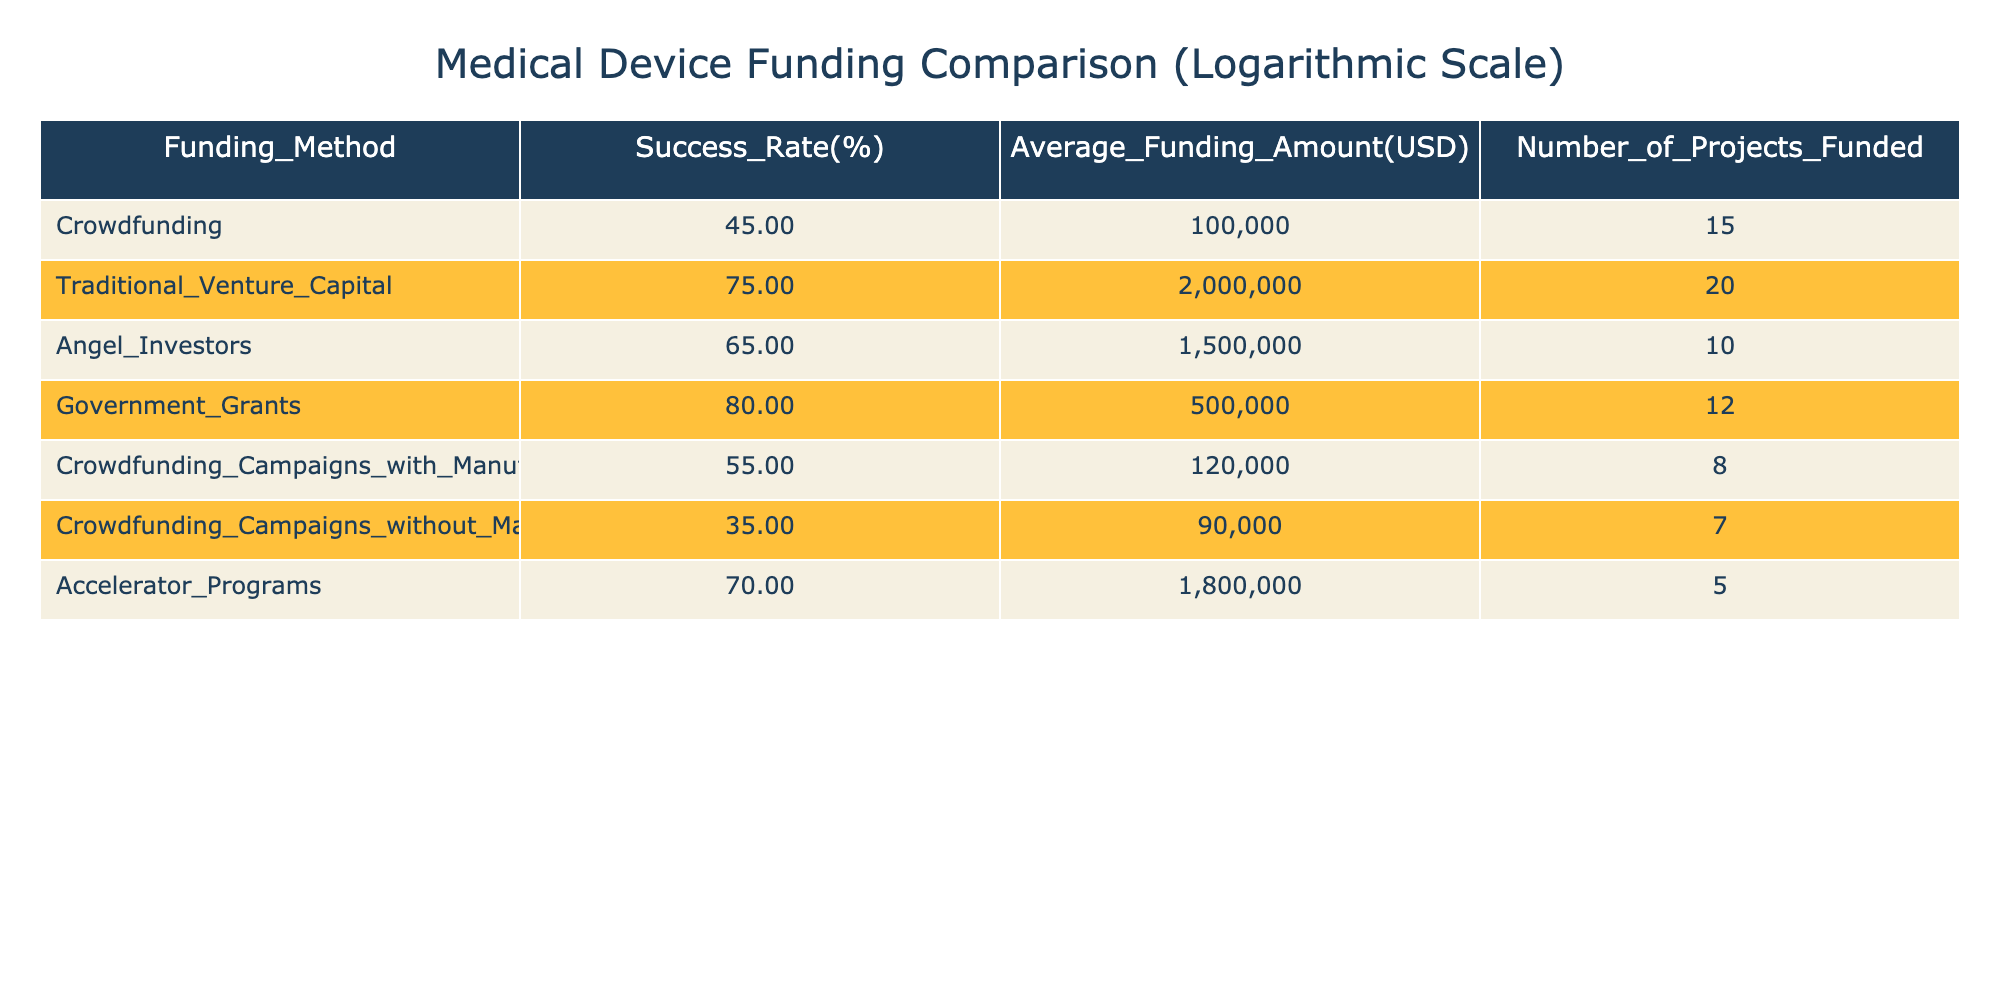What is the success rate of crowdfunding for medical devices? The table indicates that the success rate for crowdfunding is 45%.
Answer: 45% Which funding method has the highest average funding amount? The funding method with the highest average funding amount is Traditional Venture Capital, with an amount of 2,000,000 USD.
Answer: 2,000,000 USD What is the average success rate of crowdfunding campaigns that do not involve manufacturers? The success rate for crowdfunding campaigns without manufacturers is 35%.
Answer: 35% What is the difference in success rates between traditional venture capital and crowdfunding? Traditional venture capital has a success rate of 75% while crowdfunding has a success rate of 45%. The difference is 75% - 45% = 30%.
Answer: 30% Is the success rate of government grants higher than that of angel investors? Yes, the success rate of government grants is 80%, which is higher than the 65% success rate of angel investors.
Answer: Yes How many projects were funded through government grants? The table shows that 12 projects were funded through government grants.
Answer: 12 What is the average funding amount of crowdfunding campaigns with manufacturers compared to those without? The average funding amount for crowdfunding campaigns with manufacturers is 120,000 USD, while for those without manufacturers, it is 90,000 USD. Therefore, the difference is 120,000 USD - 90,000 USD = 30,000 USD.
Answer: 30,000 USD Are accelerator programs more successful than crowdfunding campaigns with manufacturers? Yes, accelerator programs have a success rate of 70%, which is higher than the 55% success rate of crowdfunding campaigns with manufacturers.
Answer: Yes If you combine the number of projects funded through crowdfunding (both with and without manufacturers), how many projects were funded in total? The total number of projects funded through crowdfunding is 15 (with manufacturers) + 7 (without manufacturers) = 22 projects.
Answer: 22 